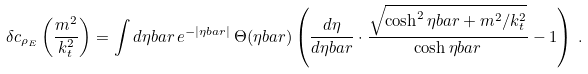<formula> <loc_0><loc_0><loc_500><loc_500>\delta c _ { \rho _ { E } } \left ( \frac { m ^ { 2 } } { k _ { t } ^ { 2 } } \right ) = \int d \eta b a r \, e ^ { - | \eta b a r | } \, \Theta ( \eta b a r ) \left ( \frac { d \eta } { d \eta b a r } \cdot \frac { \sqrt { \cosh ^ { 2 } \eta b a r + m ^ { 2 } / k _ { t } ^ { 2 } } } { \cosh \eta b a r } - 1 \right ) \, .</formula> 